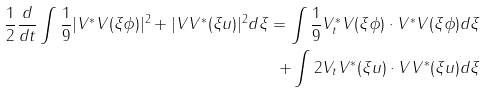Convert formula to latex. <formula><loc_0><loc_0><loc_500><loc_500>\frac { 1 } { 2 } \frac { d } { d t } \int \frac { 1 } { 9 } | V ^ { \ast } V ( \xi \phi ) | ^ { 2 } + | V V ^ { \ast } ( \xi u ) | ^ { 2 } d \xi = \int \frac { 1 } { 9 } V _ { t } ^ { \ast } V ( \xi \phi ) \cdot V ^ { \ast } V ( \xi \phi ) d \xi \\ + \int 2 V _ { t } V ^ { \ast } ( \xi u ) \cdot V V ^ { \ast } ( \xi u ) d \xi</formula> 